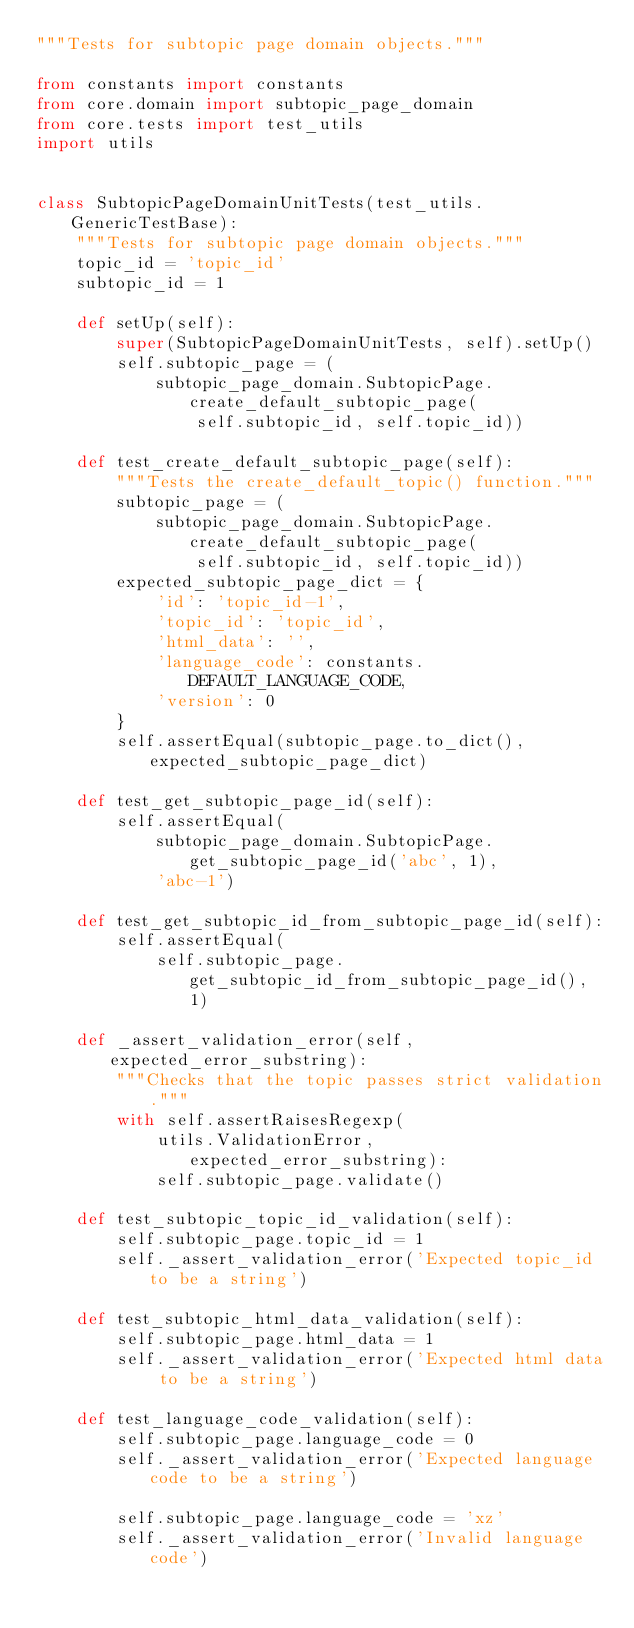Convert code to text. <code><loc_0><loc_0><loc_500><loc_500><_Python_>"""Tests for subtopic page domain objects."""

from constants import constants
from core.domain import subtopic_page_domain
from core.tests import test_utils
import utils


class SubtopicPageDomainUnitTests(test_utils.GenericTestBase):
    """Tests for subtopic page domain objects."""
    topic_id = 'topic_id'
    subtopic_id = 1

    def setUp(self):
        super(SubtopicPageDomainUnitTests, self).setUp()
        self.subtopic_page = (
            subtopic_page_domain.SubtopicPage.create_default_subtopic_page(
                self.subtopic_id, self.topic_id))

    def test_create_default_subtopic_page(self):
        """Tests the create_default_topic() function."""
        subtopic_page = (
            subtopic_page_domain.SubtopicPage.create_default_subtopic_page(
                self.subtopic_id, self.topic_id))
        expected_subtopic_page_dict = {
            'id': 'topic_id-1',
            'topic_id': 'topic_id',
            'html_data': '',
            'language_code': constants.DEFAULT_LANGUAGE_CODE,
            'version': 0
        }
        self.assertEqual(subtopic_page.to_dict(), expected_subtopic_page_dict)

    def test_get_subtopic_page_id(self):
        self.assertEqual(
            subtopic_page_domain.SubtopicPage.get_subtopic_page_id('abc', 1),
            'abc-1')

    def test_get_subtopic_id_from_subtopic_page_id(self):
        self.assertEqual(
            self.subtopic_page.get_subtopic_id_from_subtopic_page_id(), 1)

    def _assert_validation_error(self, expected_error_substring):
        """Checks that the topic passes strict validation."""
        with self.assertRaisesRegexp(
            utils.ValidationError, expected_error_substring):
            self.subtopic_page.validate()

    def test_subtopic_topic_id_validation(self):
        self.subtopic_page.topic_id = 1
        self._assert_validation_error('Expected topic_id to be a string')

    def test_subtopic_html_data_validation(self):
        self.subtopic_page.html_data = 1
        self._assert_validation_error('Expected html data to be a string')

    def test_language_code_validation(self):
        self.subtopic_page.language_code = 0
        self._assert_validation_error('Expected language code to be a string')

        self.subtopic_page.language_code = 'xz'
        self._assert_validation_error('Invalid language code')
</code> 